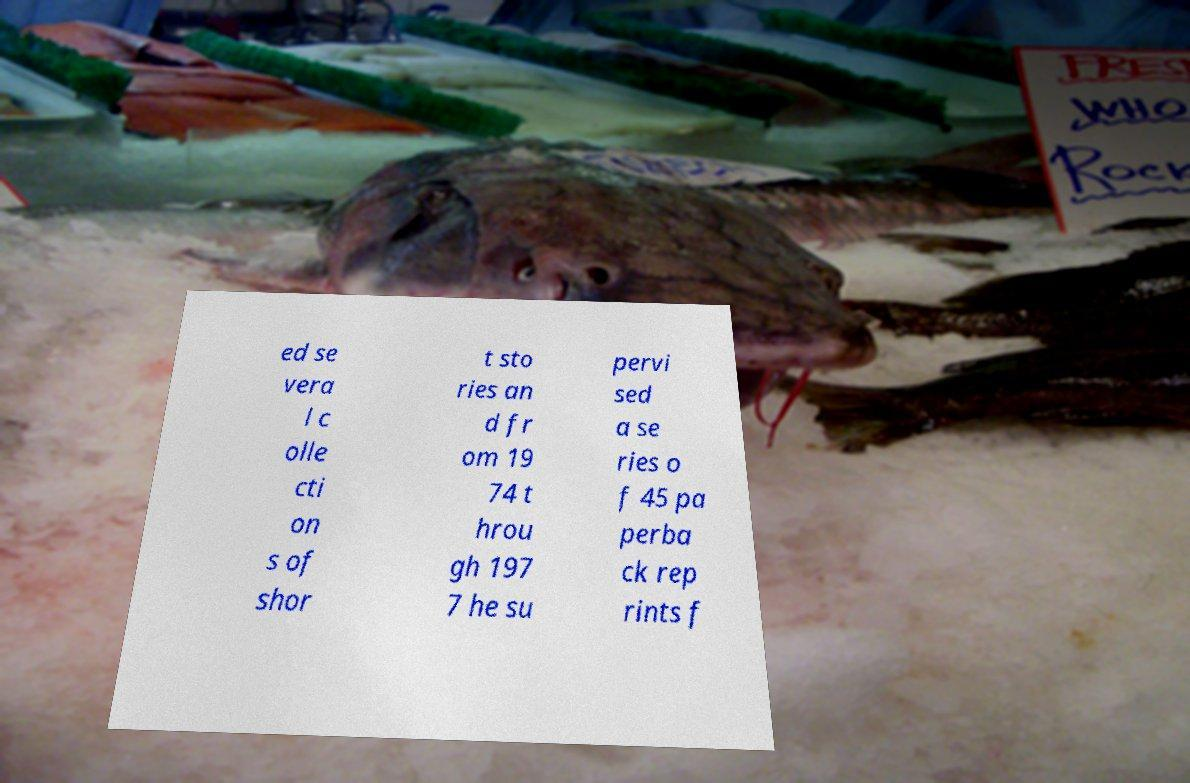Can you read and provide the text displayed in the image?This photo seems to have some interesting text. Can you extract and type it out for me? ed se vera l c olle cti on s of shor t sto ries an d fr om 19 74 t hrou gh 197 7 he su pervi sed a se ries o f 45 pa perba ck rep rints f 